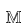Convert formula to latex. <formula><loc_0><loc_0><loc_500><loc_500>\mathbb { M }</formula> 